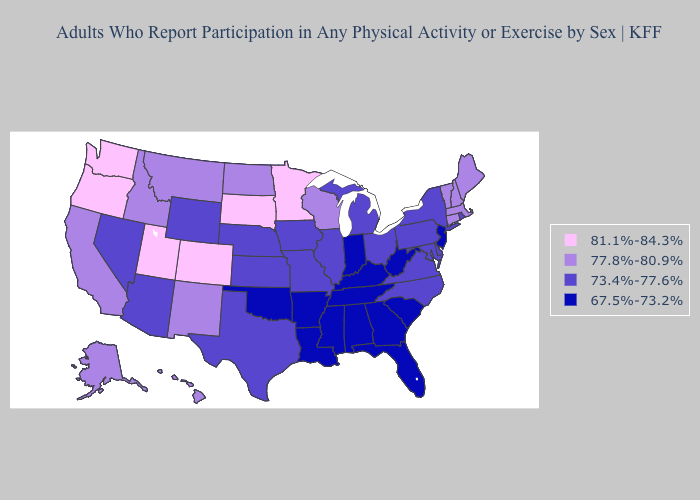What is the value of Arizona?
Be succinct. 73.4%-77.6%. Does Colorado have the highest value in the USA?
Write a very short answer. Yes. What is the highest value in states that border Mississippi?
Write a very short answer. 67.5%-73.2%. Does the first symbol in the legend represent the smallest category?
Quick response, please. No. What is the lowest value in the Northeast?
Short answer required. 67.5%-73.2%. What is the value of Georgia?
Quick response, please. 67.5%-73.2%. What is the value of Washington?
Be succinct. 81.1%-84.3%. What is the value of Louisiana?
Concise answer only. 67.5%-73.2%. What is the value of Pennsylvania?
Write a very short answer. 73.4%-77.6%. What is the value of Nevada?
Short answer required. 73.4%-77.6%. What is the lowest value in the USA?
Write a very short answer. 67.5%-73.2%. Among the states that border Alabama , which have the highest value?
Quick response, please. Florida, Georgia, Mississippi, Tennessee. Does Florida have a lower value than Kentucky?
Short answer required. No. How many symbols are there in the legend?
Be succinct. 4. Among the states that border Arizona , which have the highest value?
Concise answer only. Colorado, Utah. 